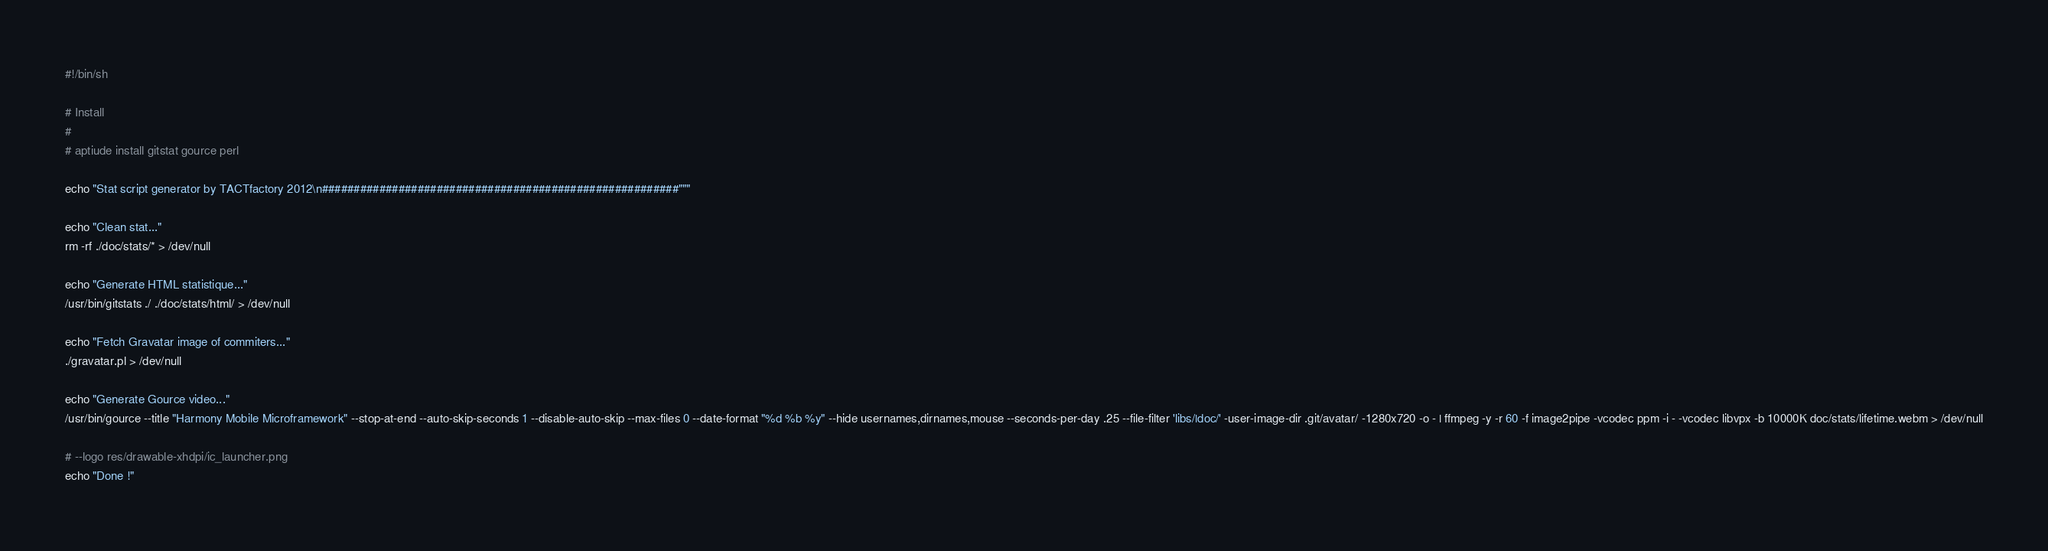Convert code to text. <code><loc_0><loc_0><loc_500><loc_500><_Bash_>#!/bin/sh

# Install
#
# aptiude install gitstat gource perl

echo "Stat script generator by TACTfactory 2012\n########################################################"""

echo "Clean stat..."
rm -rf ./doc/stats/* > /dev/null

echo "Generate HTML statistique..."
/usr/bin/gitstats ./ ./doc/stats/html/ > /dev/null

echo "Fetch Gravatar image of commiters..."
./gravatar.pl > /dev/null

echo "Generate Gource video..."
/usr/bin/gource --title "Harmony Mobile Microframework" --stop-at-end --auto-skip-seconds 1 --disable-auto-skip --max-files 0 --date-format "%d %b %y" --hide usernames,dirnames,mouse --seconds-per-day .25 --file-filter 'libs/|doc/' -user-image-dir .git/avatar/ -1280x720 -o - | ffmpeg -y -r 60 -f image2pipe -vcodec ppm -i - -vcodec libvpx -b 10000K doc/stats/lifetime.webm > /dev/null

# --logo res/drawable-xhdpi/ic_launcher.png
echo "Done !"
</code> 